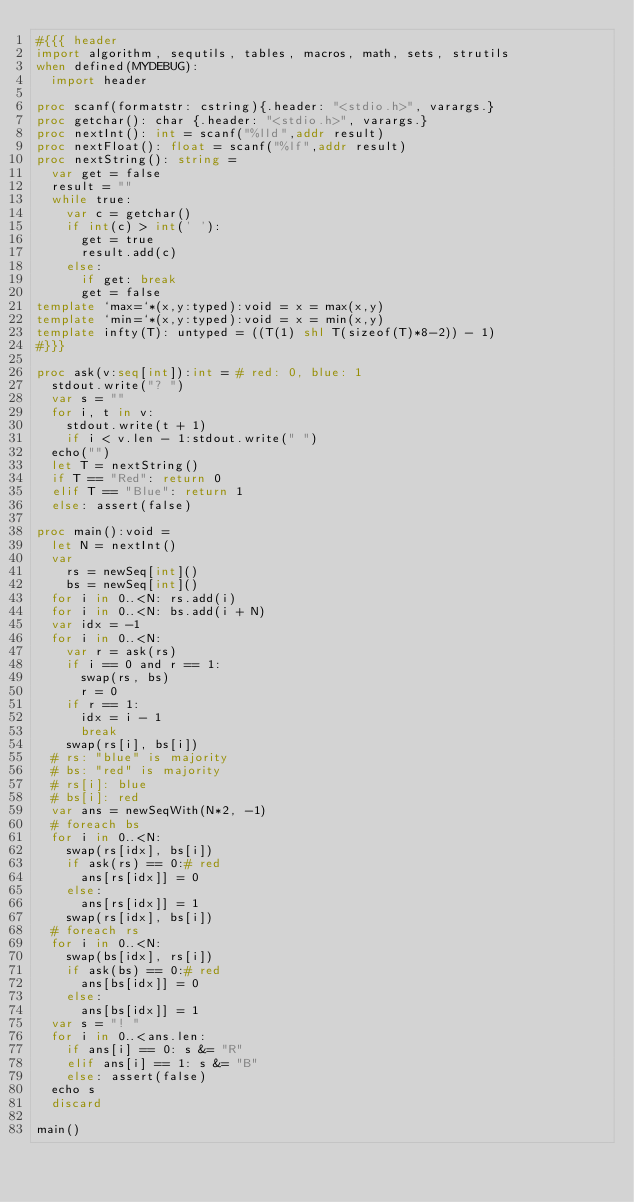<code> <loc_0><loc_0><loc_500><loc_500><_Nim_>#{{{ header
import algorithm, sequtils, tables, macros, math, sets, strutils
when defined(MYDEBUG):
  import header

proc scanf(formatstr: cstring){.header: "<stdio.h>", varargs.}
proc getchar(): char {.header: "<stdio.h>", varargs.}
proc nextInt(): int = scanf("%lld",addr result)
proc nextFloat(): float = scanf("%lf",addr result)
proc nextString(): string =
  var get = false
  result = ""
  while true:
    var c = getchar()
    if int(c) > int(' '):
      get = true
      result.add(c)
    else:
      if get: break
      get = false
template `max=`*(x,y:typed):void = x = max(x,y)
template `min=`*(x,y:typed):void = x = min(x,y)
template infty(T): untyped = ((T(1) shl T(sizeof(T)*8-2)) - 1)
#}}}

proc ask(v:seq[int]):int = # red: 0, blue: 1
  stdout.write("? ")
  var s = ""
  for i, t in v:
    stdout.write(t + 1)
    if i < v.len - 1:stdout.write(" ")
  echo("")
  let T = nextString()
  if T == "Red": return 0
  elif T == "Blue": return 1
  else: assert(false)

proc main():void =
  let N = nextInt()
  var
    rs = newSeq[int]()
    bs = newSeq[int]()
  for i in 0..<N: rs.add(i)
  for i in 0..<N: bs.add(i + N)
  var idx = -1
  for i in 0..<N:
    var r = ask(rs)
    if i == 0 and r == 1:
      swap(rs, bs)
      r = 0
    if r == 1:
      idx = i - 1
      break
    swap(rs[i], bs[i])
  # rs: "blue" is majority
  # bs: "red" is majority
  # rs[i]: blue
  # bs[i]: red
  var ans = newSeqWith(N*2, -1)
  # foreach bs
  for i in 0..<N:
    swap(rs[idx], bs[i])
    if ask(rs) == 0:# red
      ans[rs[idx]] = 0
    else:
      ans[rs[idx]] = 1
    swap(rs[idx], bs[i])
  # foreach rs
  for i in 0..<N:
    swap(bs[idx], rs[i])
    if ask(bs) == 0:# red
      ans[bs[idx]] = 0
    else:
      ans[bs[idx]] = 1
  var s = "! "
  for i in 0..<ans.len:
    if ans[i] == 0: s &= "R"
    elif ans[i] == 1: s &= "B"
    else: assert(false)
  echo s
  discard

main()
</code> 